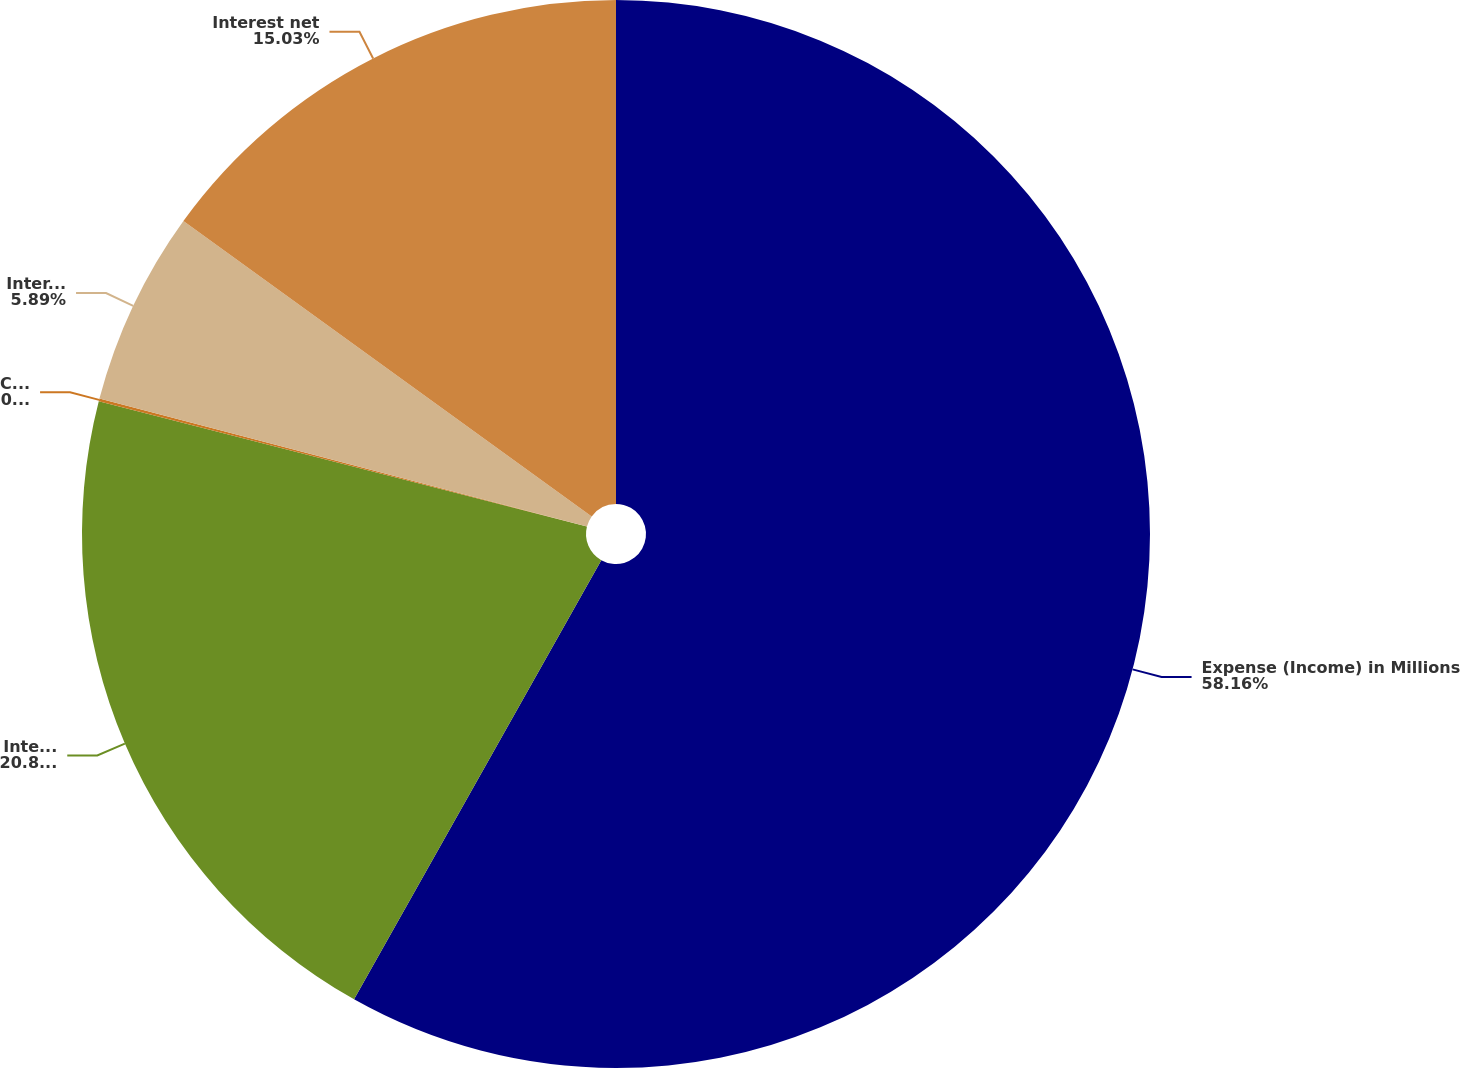Convert chart to OTSL. <chart><loc_0><loc_0><loc_500><loc_500><pie_chart><fcel>Expense (Income) in Millions<fcel>Interest expense<fcel>Capitalized interest<fcel>Interest income<fcel>Interest net<nl><fcel>58.16%<fcel>20.84%<fcel>0.08%<fcel>5.89%<fcel>15.03%<nl></chart> 